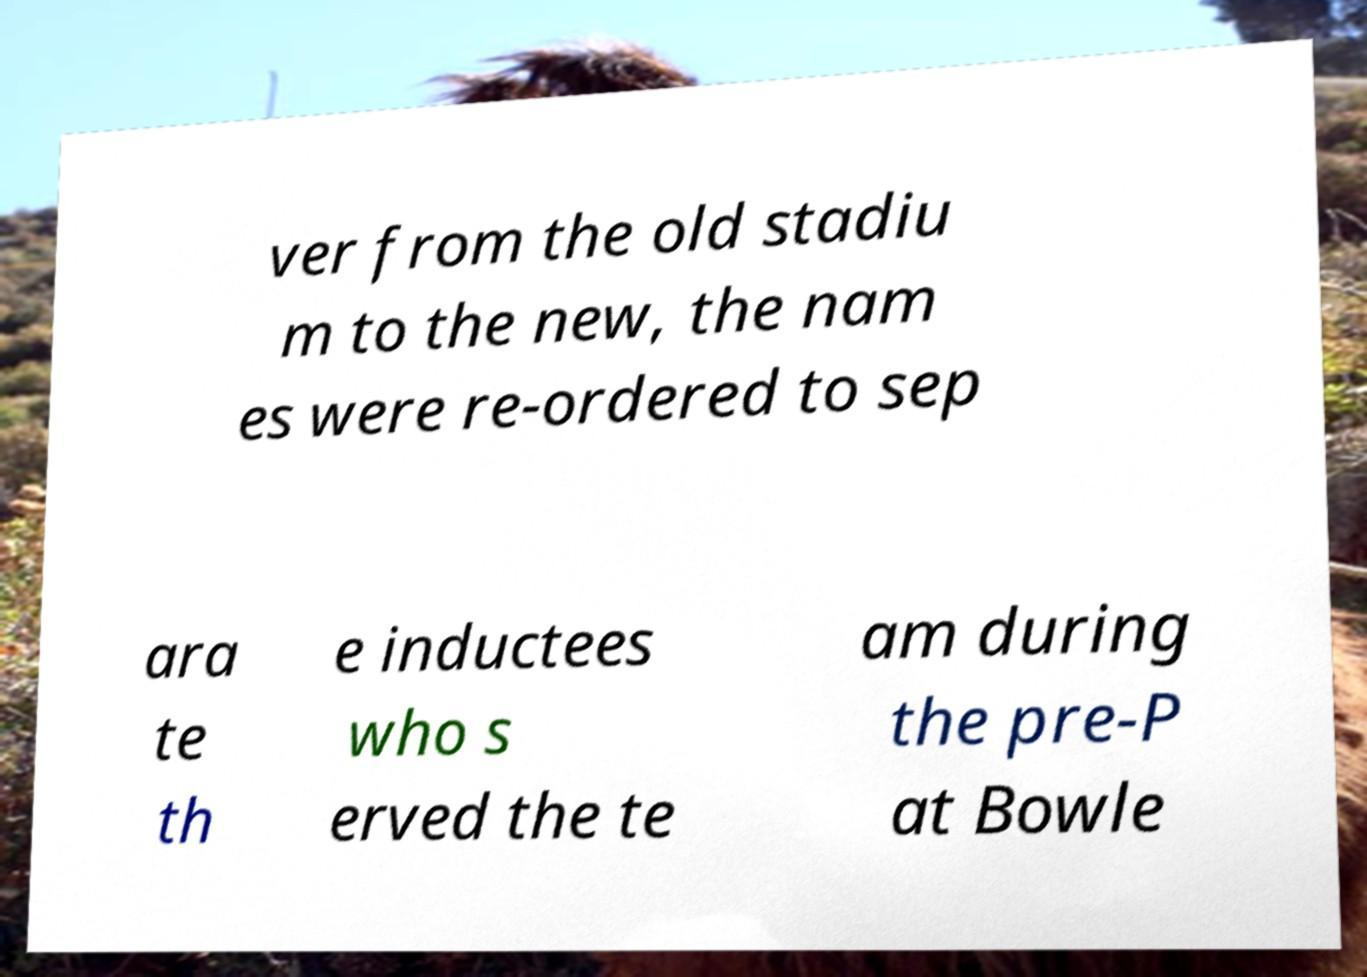For documentation purposes, I need the text within this image transcribed. Could you provide that? ver from the old stadiu m to the new, the nam es were re-ordered to sep ara te th e inductees who s erved the te am during the pre-P at Bowle 